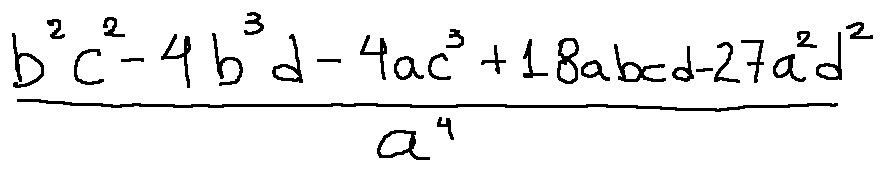Convert formula to latex. <formula><loc_0><loc_0><loc_500><loc_500>\frac { b ^ { 2 } c ^ { 2 } - 4 b ^ { 3 } d - 4 a c ^ { 3 } + 1 8 a b c d - 2 7 a ^ { 2 } d ^ { 2 } } { a ^ { 4 } }</formula> 